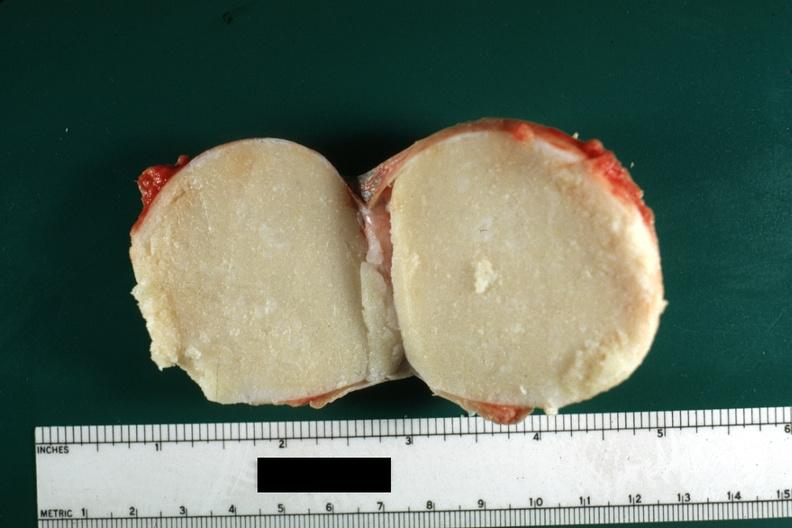does % show cut surface typical cheese like yellow content and thin fibrous capsule this lesion was from the scrotal skin?
Answer the question using a single word or phrase. No 